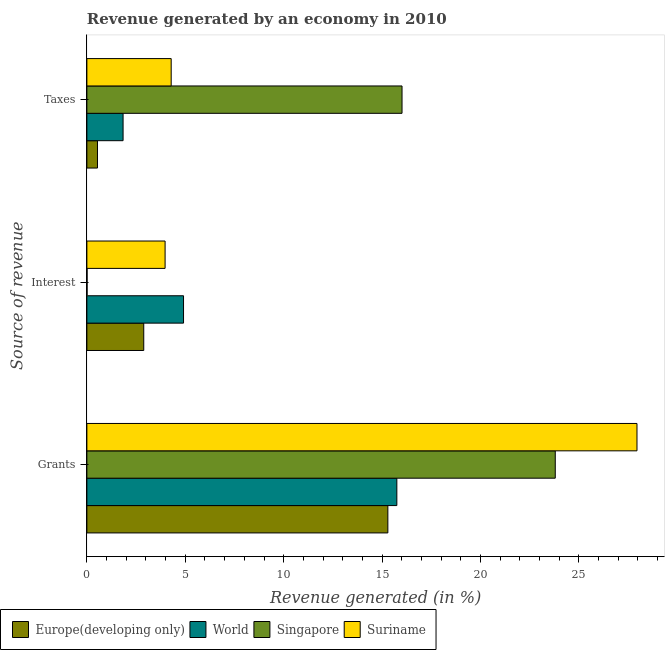How many different coloured bars are there?
Your response must be concise. 4. Are the number of bars on each tick of the Y-axis equal?
Your response must be concise. Yes. How many bars are there on the 2nd tick from the top?
Your answer should be very brief. 4. What is the label of the 3rd group of bars from the top?
Give a very brief answer. Grants. What is the percentage of revenue generated by interest in Singapore?
Provide a short and direct response. 0.01. Across all countries, what is the maximum percentage of revenue generated by interest?
Provide a succinct answer. 4.91. Across all countries, what is the minimum percentage of revenue generated by interest?
Provide a short and direct response. 0.01. In which country was the percentage of revenue generated by grants maximum?
Provide a short and direct response. Suriname. In which country was the percentage of revenue generated by taxes minimum?
Offer a terse response. Europe(developing only). What is the total percentage of revenue generated by interest in the graph?
Make the answer very short. 11.78. What is the difference between the percentage of revenue generated by taxes in Suriname and that in Europe(developing only)?
Offer a very short reply. 3.74. What is the difference between the percentage of revenue generated by grants in Europe(developing only) and the percentage of revenue generated by interest in Singapore?
Your answer should be very brief. 15.28. What is the average percentage of revenue generated by taxes per country?
Offer a very short reply. 5.67. What is the difference between the percentage of revenue generated by interest and percentage of revenue generated by taxes in Singapore?
Your answer should be very brief. -16. What is the ratio of the percentage of revenue generated by taxes in Suriname to that in Singapore?
Provide a succinct answer. 0.27. What is the difference between the highest and the second highest percentage of revenue generated by interest?
Ensure brevity in your answer.  0.94. What is the difference between the highest and the lowest percentage of revenue generated by interest?
Provide a short and direct response. 4.9. Is the sum of the percentage of revenue generated by interest in Suriname and World greater than the maximum percentage of revenue generated by grants across all countries?
Offer a terse response. No. Is it the case that in every country, the sum of the percentage of revenue generated by grants and percentage of revenue generated by interest is greater than the percentage of revenue generated by taxes?
Your answer should be very brief. Yes. How many bars are there?
Make the answer very short. 12. Are all the bars in the graph horizontal?
Provide a succinct answer. Yes. How many countries are there in the graph?
Your answer should be compact. 4. How are the legend labels stacked?
Ensure brevity in your answer.  Horizontal. What is the title of the graph?
Keep it short and to the point. Revenue generated by an economy in 2010. Does "Sint Maarten (Dutch part)" appear as one of the legend labels in the graph?
Your response must be concise. No. What is the label or title of the X-axis?
Provide a short and direct response. Revenue generated (in %). What is the label or title of the Y-axis?
Keep it short and to the point. Source of revenue. What is the Revenue generated (in %) in Europe(developing only) in Grants?
Your answer should be compact. 15.29. What is the Revenue generated (in %) of World in Grants?
Provide a succinct answer. 15.75. What is the Revenue generated (in %) of Singapore in Grants?
Offer a terse response. 23.8. What is the Revenue generated (in %) of Suriname in Grants?
Keep it short and to the point. 27.95. What is the Revenue generated (in %) in Europe(developing only) in Interest?
Provide a succinct answer. 2.89. What is the Revenue generated (in %) of World in Interest?
Provide a short and direct response. 4.91. What is the Revenue generated (in %) of Singapore in Interest?
Give a very brief answer. 0.01. What is the Revenue generated (in %) in Suriname in Interest?
Your response must be concise. 3.97. What is the Revenue generated (in %) in Europe(developing only) in Taxes?
Your answer should be compact. 0.54. What is the Revenue generated (in %) of World in Taxes?
Your answer should be compact. 1.84. What is the Revenue generated (in %) of Singapore in Taxes?
Provide a short and direct response. 16.01. What is the Revenue generated (in %) of Suriname in Taxes?
Offer a very short reply. 4.28. Across all Source of revenue, what is the maximum Revenue generated (in %) of Europe(developing only)?
Provide a succinct answer. 15.29. Across all Source of revenue, what is the maximum Revenue generated (in %) of World?
Provide a short and direct response. 15.75. Across all Source of revenue, what is the maximum Revenue generated (in %) in Singapore?
Provide a succinct answer. 23.8. Across all Source of revenue, what is the maximum Revenue generated (in %) in Suriname?
Keep it short and to the point. 27.95. Across all Source of revenue, what is the minimum Revenue generated (in %) in Europe(developing only)?
Ensure brevity in your answer.  0.54. Across all Source of revenue, what is the minimum Revenue generated (in %) of World?
Your response must be concise. 1.84. Across all Source of revenue, what is the minimum Revenue generated (in %) of Singapore?
Your answer should be very brief. 0.01. Across all Source of revenue, what is the minimum Revenue generated (in %) of Suriname?
Offer a very short reply. 3.97. What is the total Revenue generated (in %) of Europe(developing only) in the graph?
Provide a short and direct response. 18.72. What is the total Revenue generated (in %) in Singapore in the graph?
Provide a succinct answer. 39.82. What is the total Revenue generated (in %) in Suriname in the graph?
Give a very brief answer. 36.21. What is the difference between the Revenue generated (in %) of Europe(developing only) in Grants and that in Interest?
Offer a terse response. 12.4. What is the difference between the Revenue generated (in %) in World in Grants and that in Interest?
Your response must be concise. 10.84. What is the difference between the Revenue generated (in %) of Singapore in Grants and that in Interest?
Keep it short and to the point. 23.79. What is the difference between the Revenue generated (in %) in Suriname in Grants and that in Interest?
Provide a short and direct response. 23.98. What is the difference between the Revenue generated (in %) in Europe(developing only) in Grants and that in Taxes?
Your answer should be very brief. 14.75. What is the difference between the Revenue generated (in %) of World in Grants and that in Taxes?
Offer a terse response. 13.91. What is the difference between the Revenue generated (in %) of Singapore in Grants and that in Taxes?
Provide a succinct answer. 7.79. What is the difference between the Revenue generated (in %) of Suriname in Grants and that in Taxes?
Provide a succinct answer. 23.67. What is the difference between the Revenue generated (in %) of Europe(developing only) in Interest and that in Taxes?
Your response must be concise. 2.35. What is the difference between the Revenue generated (in %) of World in Interest and that in Taxes?
Offer a very short reply. 3.07. What is the difference between the Revenue generated (in %) in Singapore in Interest and that in Taxes?
Make the answer very short. -16. What is the difference between the Revenue generated (in %) in Suriname in Interest and that in Taxes?
Your response must be concise. -0.31. What is the difference between the Revenue generated (in %) in Europe(developing only) in Grants and the Revenue generated (in %) in World in Interest?
Your answer should be compact. 10.38. What is the difference between the Revenue generated (in %) of Europe(developing only) in Grants and the Revenue generated (in %) of Singapore in Interest?
Ensure brevity in your answer.  15.28. What is the difference between the Revenue generated (in %) in Europe(developing only) in Grants and the Revenue generated (in %) in Suriname in Interest?
Your response must be concise. 11.32. What is the difference between the Revenue generated (in %) in World in Grants and the Revenue generated (in %) in Singapore in Interest?
Provide a succinct answer. 15.74. What is the difference between the Revenue generated (in %) of World in Grants and the Revenue generated (in %) of Suriname in Interest?
Your answer should be very brief. 11.78. What is the difference between the Revenue generated (in %) of Singapore in Grants and the Revenue generated (in %) of Suriname in Interest?
Offer a terse response. 19.82. What is the difference between the Revenue generated (in %) of Europe(developing only) in Grants and the Revenue generated (in %) of World in Taxes?
Your response must be concise. 13.45. What is the difference between the Revenue generated (in %) in Europe(developing only) in Grants and the Revenue generated (in %) in Singapore in Taxes?
Give a very brief answer. -0.72. What is the difference between the Revenue generated (in %) of Europe(developing only) in Grants and the Revenue generated (in %) of Suriname in Taxes?
Make the answer very short. 11.01. What is the difference between the Revenue generated (in %) of World in Grants and the Revenue generated (in %) of Singapore in Taxes?
Make the answer very short. -0.26. What is the difference between the Revenue generated (in %) of World in Grants and the Revenue generated (in %) of Suriname in Taxes?
Offer a terse response. 11.47. What is the difference between the Revenue generated (in %) of Singapore in Grants and the Revenue generated (in %) of Suriname in Taxes?
Offer a terse response. 19.52. What is the difference between the Revenue generated (in %) of Europe(developing only) in Interest and the Revenue generated (in %) of World in Taxes?
Your response must be concise. 1.05. What is the difference between the Revenue generated (in %) in Europe(developing only) in Interest and the Revenue generated (in %) in Singapore in Taxes?
Your response must be concise. -13.12. What is the difference between the Revenue generated (in %) in Europe(developing only) in Interest and the Revenue generated (in %) in Suriname in Taxes?
Offer a terse response. -1.39. What is the difference between the Revenue generated (in %) in World in Interest and the Revenue generated (in %) in Singapore in Taxes?
Provide a succinct answer. -11.1. What is the difference between the Revenue generated (in %) in World in Interest and the Revenue generated (in %) in Suriname in Taxes?
Provide a succinct answer. 0.63. What is the difference between the Revenue generated (in %) in Singapore in Interest and the Revenue generated (in %) in Suriname in Taxes?
Your response must be concise. -4.27. What is the average Revenue generated (in %) in Europe(developing only) per Source of revenue?
Offer a terse response. 6.24. What is the average Revenue generated (in %) of Singapore per Source of revenue?
Offer a very short reply. 13.27. What is the average Revenue generated (in %) in Suriname per Source of revenue?
Give a very brief answer. 12.07. What is the difference between the Revenue generated (in %) of Europe(developing only) and Revenue generated (in %) of World in Grants?
Your answer should be compact. -0.46. What is the difference between the Revenue generated (in %) in Europe(developing only) and Revenue generated (in %) in Singapore in Grants?
Keep it short and to the point. -8.51. What is the difference between the Revenue generated (in %) in Europe(developing only) and Revenue generated (in %) in Suriname in Grants?
Your answer should be very brief. -12.66. What is the difference between the Revenue generated (in %) in World and Revenue generated (in %) in Singapore in Grants?
Make the answer very short. -8.05. What is the difference between the Revenue generated (in %) of World and Revenue generated (in %) of Suriname in Grants?
Provide a succinct answer. -12.2. What is the difference between the Revenue generated (in %) of Singapore and Revenue generated (in %) of Suriname in Grants?
Your response must be concise. -4.15. What is the difference between the Revenue generated (in %) of Europe(developing only) and Revenue generated (in %) of World in Interest?
Your answer should be very brief. -2.02. What is the difference between the Revenue generated (in %) in Europe(developing only) and Revenue generated (in %) in Singapore in Interest?
Keep it short and to the point. 2.88. What is the difference between the Revenue generated (in %) of Europe(developing only) and Revenue generated (in %) of Suriname in Interest?
Provide a succinct answer. -1.08. What is the difference between the Revenue generated (in %) of World and Revenue generated (in %) of Singapore in Interest?
Your answer should be compact. 4.9. What is the difference between the Revenue generated (in %) of World and Revenue generated (in %) of Suriname in Interest?
Your response must be concise. 0.94. What is the difference between the Revenue generated (in %) in Singapore and Revenue generated (in %) in Suriname in Interest?
Offer a very short reply. -3.96. What is the difference between the Revenue generated (in %) of Europe(developing only) and Revenue generated (in %) of World in Taxes?
Give a very brief answer. -1.3. What is the difference between the Revenue generated (in %) of Europe(developing only) and Revenue generated (in %) of Singapore in Taxes?
Ensure brevity in your answer.  -15.47. What is the difference between the Revenue generated (in %) in Europe(developing only) and Revenue generated (in %) in Suriname in Taxes?
Offer a very short reply. -3.74. What is the difference between the Revenue generated (in %) in World and Revenue generated (in %) in Singapore in Taxes?
Give a very brief answer. -14.17. What is the difference between the Revenue generated (in %) in World and Revenue generated (in %) in Suriname in Taxes?
Offer a terse response. -2.44. What is the difference between the Revenue generated (in %) of Singapore and Revenue generated (in %) of Suriname in Taxes?
Your answer should be compact. 11.73. What is the ratio of the Revenue generated (in %) in Europe(developing only) in Grants to that in Interest?
Your response must be concise. 5.29. What is the ratio of the Revenue generated (in %) of World in Grants to that in Interest?
Your answer should be very brief. 3.21. What is the ratio of the Revenue generated (in %) in Singapore in Grants to that in Interest?
Your answer should be compact. 2417.98. What is the ratio of the Revenue generated (in %) in Suriname in Grants to that in Interest?
Provide a succinct answer. 7.03. What is the ratio of the Revenue generated (in %) in Europe(developing only) in Grants to that in Taxes?
Keep it short and to the point. 28.37. What is the ratio of the Revenue generated (in %) of World in Grants to that in Taxes?
Ensure brevity in your answer.  8.56. What is the ratio of the Revenue generated (in %) of Singapore in Grants to that in Taxes?
Your response must be concise. 1.49. What is the ratio of the Revenue generated (in %) of Suriname in Grants to that in Taxes?
Make the answer very short. 6.53. What is the ratio of the Revenue generated (in %) of Europe(developing only) in Interest to that in Taxes?
Provide a succinct answer. 5.36. What is the ratio of the Revenue generated (in %) in World in Interest to that in Taxes?
Your answer should be very brief. 2.67. What is the ratio of the Revenue generated (in %) of Singapore in Interest to that in Taxes?
Give a very brief answer. 0. What is the ratio of the Revenue generated (in %) of Suriname in Interest to that in Taxes?
Your response must be concise. 0.93. What is the difference between the highest and the second highest Revenue generated (in %) in Europe(developing only)?
Keep it short and to the point. 12.4. What is the difference between the highest and the second highest Revenue generated (in %) of World?
Make the answer very short. 10.84. What is the difference between the highest and the second highest Revenue generated (in %) of Singapore?
Make the answer very short. 7.79. What is the difference between the highest and the second highest Revenue generated (in %) in Suriname?
Ensure brevity in your answer.  23.67. What is the difference between the highest and the lowest Revenue generated (in %) in Europe(developing only)?
Make the answer very short. 14.75. What is the difference between the highest and the lowest Revenue generated (in %) in World?
Your answer should be very brief. 13.91. What is the difference between the highest and the lowest Revenue generated (in %) in Singapore?
Provide a succinct answer. 23.79. What is the difference between the highest and the lowest Revenue generated (in %) in Suriname?
Give a very brief answer. 23.98. 